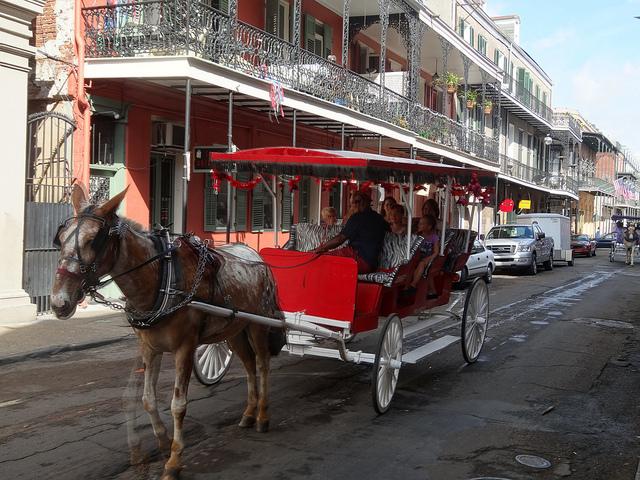What is the horse doing?
Short answer required. Walking. What color is the carriage painted?
Give a very brief answer. Red. Where was this photo taken?
Write a very short answer. New orleans. 